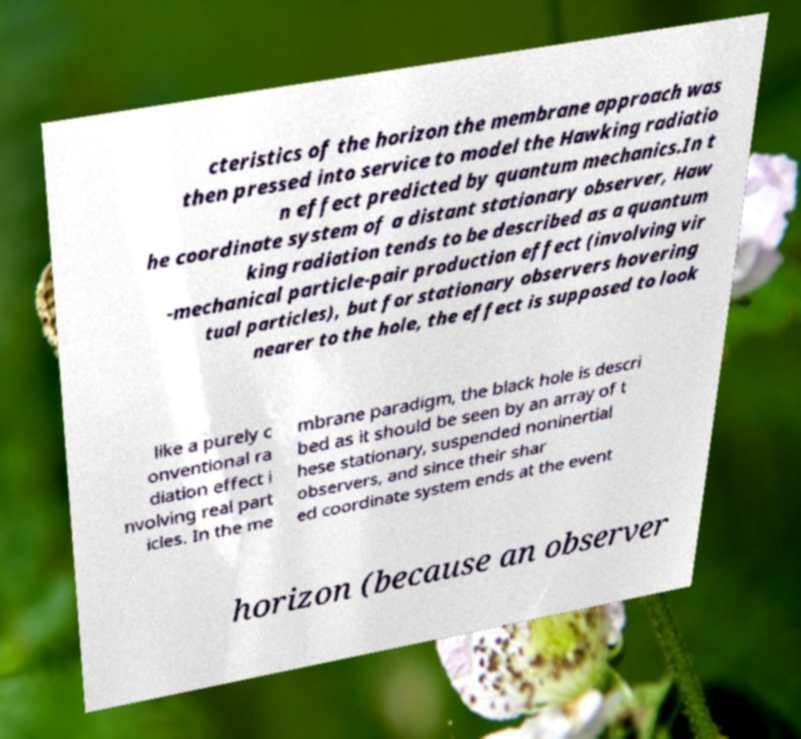Please identify and transcribe the text found in this image. cteristics of the horizon the membrane approach was then pressed into service to model the Hawking radiatio n effect predicted by quantum mechanics.In t he coordinate system of a distant stationary observer, Haw king radiation tends to be described as a quantum -mechanical particle-pair production effect (involving vir tual particles), but for stationary observers hovering nearer to the hole, the effect is supposed to look like a purely c onventional ra diation effect i nvolving real part icles. In the me mbrane paradigm, the black hole is descri bed as it should be seen by an array of t hese stationary, suspended noninertial observers, and since their shar ed coordinate system ends at the event horizon (because an observer 